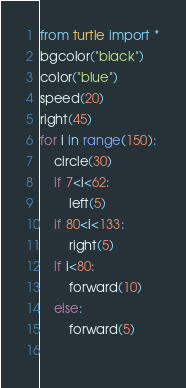Convert code to text. <code><loc_0><loc_0><loc_500><loc_500><_Python_>from turtle import *
bgcolor("black")
color("blue")
speed(20)
right(45)
for i in range(150):
    circle(30)
    if 7<i<62:
        left(5)
    if 80<i<133:
        right(5)
    if i<80:
        forward(10)
    else:
        forward(5)
    
</code> 